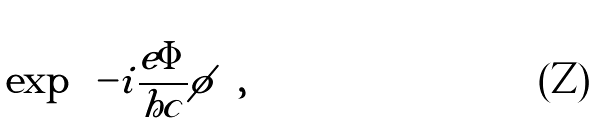<formula> <loc_0><loc_0><loc_500><loc_500>\exp { \left ( - i \frac { e \Phi } { h c } \phi \right ) } ,</formula> 